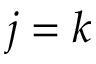<formula> <loc_0><loc_0><loc_500><loc_500>j = k</formula> 